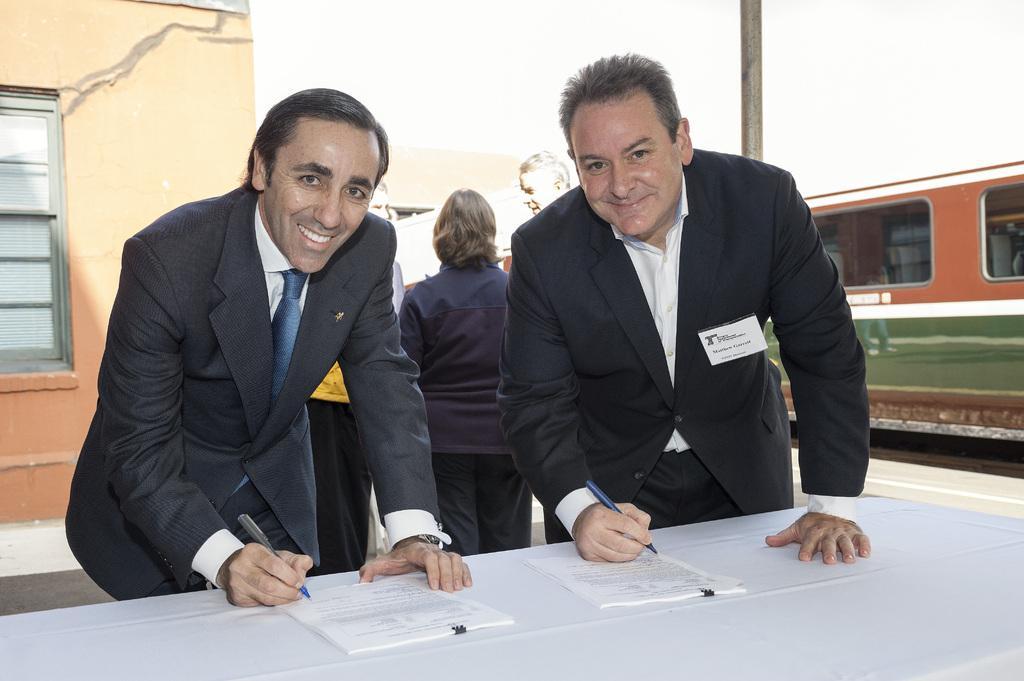Please provide a concise description of this image. 2 men are standing and smiling, holding a pen in their hands. There are papers on the table present in front them. There are other people behind them. There are buildings, pole and a train at the right. 